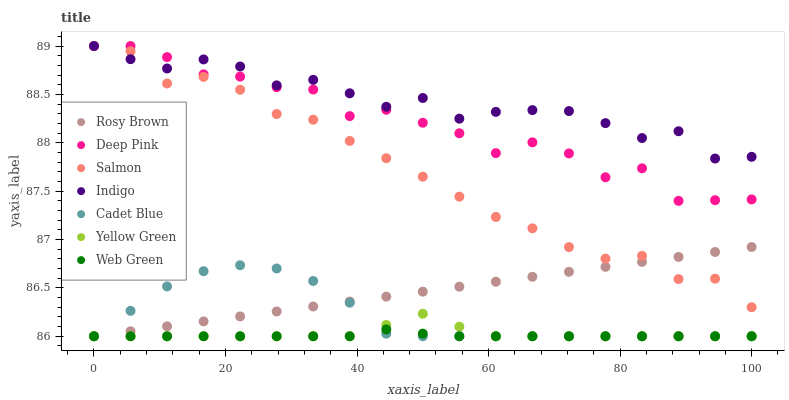Does Web Green have the minimum area under the curve?
Answer yes or no. Yes. Does Indigo have the maximum area under the curve?
Answer yes or no. Yes. Does Yellow Green have the minimum area under the curve?
Answer yes or no. No. Does Yellow Green have the maximum area under the curve?
Answer yes or no. No. Is Rosy Brown the smoothest?
Answer yes or no. Yes. Is Deep Pink the roughest?
Answer yes or no. Yes. Is Indigo the smoothest?
Answer yes or no. No. Is Indigo the roughest?
Answer yes or no. No. Does Cadet Blue have the lowest value?
Answer yes or no. Yes. Does Indigo have the lowest value?
Answer yes or no. No. Does Deep Pink have the highest value?
Answer yes or no. Yes. Does Yellow Green have the highest value?
Answer yes or no. No. Is Web Green less than Salmon?
Answer yes or no. Yes. Is Salmon greater than Web Green?
Answer yes or no. Yes. Does Cadet Blue intersect Web Green?
Answer yes or no. Yes. Is Cadet Blue less than Web Green?
Answer yes or no. No. Is Cadet Blue greater than Web Green?
Answer yes or no. No. Does Web Green intersect Salmon?
Answer yes or no. No. 